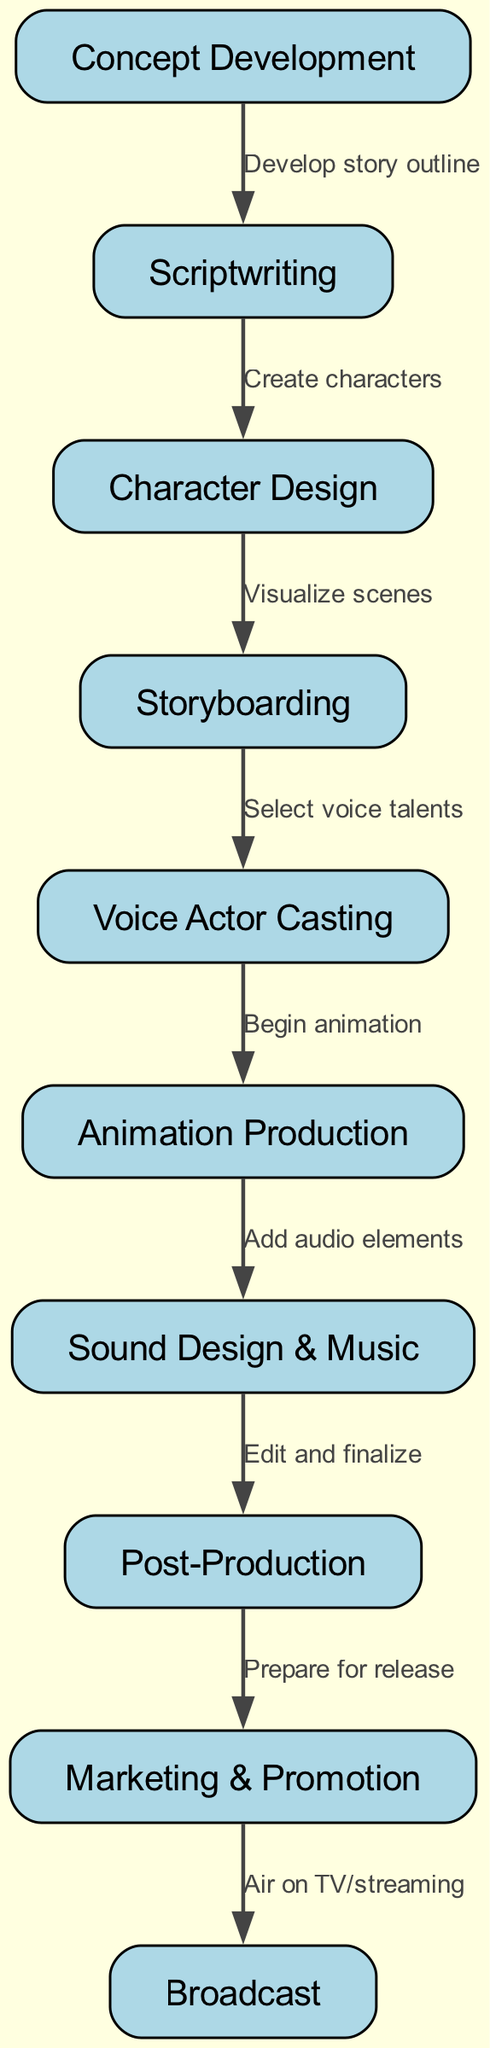What is the first step in the anime production pipeline? The first step in the pipeline, as indicated by the flow chart, is "Concept Development." This is the initiation phase where the foundational ideas for the anime are created.
Answer: Concept Development How many main steps are there in the anime production pipeline? By counting the nodes in the diagram, there are ten distinct steps (nodes) in total that outline the production process from start to finish.
Answer: Ten What follows scriptwriting in the production pipeline? After "Scriptwriting," the next step in the flow chart is "Character Design." This follows logically as once the script is written, characters need to be designed to match the story.
Answer: Character Design Which two nodes are directly connected to "Animation Production"? The node "Animation Production" has two direct connections: it comes after "Voice Actor Casting" and leads to "Sound Design & Music." This illustrates the gap between voice recording and the addition of audio elements.
Answer: Voice Actor Casting and Sound Design & Music What is the relationship between "Post-Production" and "Marketing & Promotion"? According to the flow chart, "Post-Production" directly leads to "Marketing & Promotion," indicating that once editing and finalization are complete, the promotion phase starts to prepare the anime for release.
Answer: Post-Production leads to Marketing & Promotion How many edges indicate the transitions between steps in this production pipeline? By counting the connections (edges) between nodes, there are nine edges that illustrate the transitions from one step to the next within the anime production pipeline.
Answer: Nine What is the last step before the anime is aired? The final step before the anime is broadcasted is "Prepare for release," which forms part of the marketing process to ensure the anime reaches its audience effectively.
Answer: Prepare for release Which step involves selecting voice talents? The step that involves selecting voice talents is "Voice Actor Casting." This step is crucial as it assigns voice actors to the characters that have been designed.
Answer: Voice Actor Casting What is the output of the entire production process? The final output of the production process, as shown in the last node of the flow chart, is "Air on TV/streaming." This signifies that after all preparation, the anime is successfully broadcasted.
Answer: Air on TV/streaming 